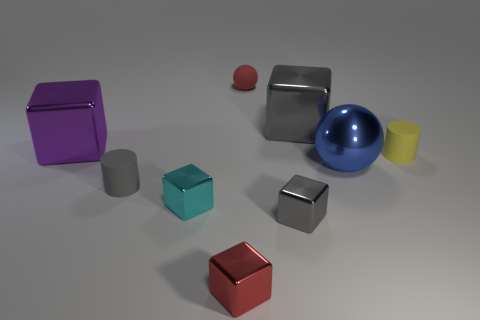Is the color of the object in front of the small gray metallic block the same as the rubber ball?
Give a very brief answer. Yes. The cyan metallic object has what size?
Ensure brevity in your answer.  Small. There is a red object in front of the large purple shiny object behind the yellow rubber thing; what is its size?
Make the answer very short. Small. What number of metal things are the same color as the small matte sphere?
Your answer should be compact. 1. What number of yellow balls are there?
Give a very brief answer. 0. How many other red cubes have the same material as the red cube?
Make the answer very short. 0. What size is the other rubber object that is the same shape as the yellow rubber thing?
Ensure brevity in your answer.  Small. What is the large blue sphere made of?
Offer a very short reply. Metal. What material is the small red thing behind the big metal thing that is in front of the tiny cylinder on the right side of the red matte thing?
Offer a terse response. Rubber. What color is the other small object that is the same shape as the yellow matte thing?
Your response must be concise. Gray. 